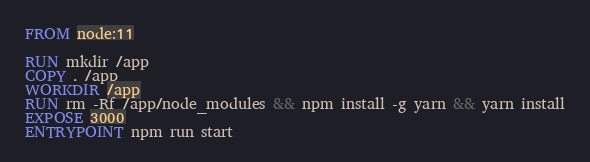Convert code to text. <code><loc_0><loc_0><loc_500><loc_500><_Dockerfile_>FROM node:11

RUN mkdir /app
COPY . /app
WORKDIR /app
RUN rm -Rf /app/node_modules && npm install -g yarn && yarn install
EXPOSE 3000
ENTRYPOINT npm run start</code> 